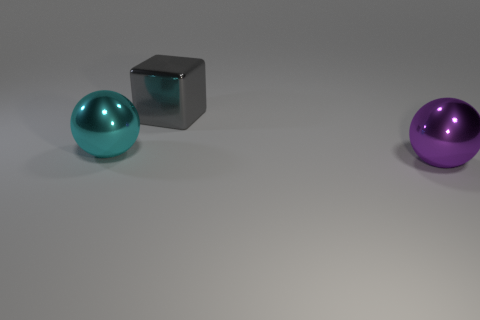The cyan sphere is what size?
Provide a short and direct response. Large. There is a large gray object that is made of the same material as the large purple ball; what shape is it?
Provide a short and direct response. Cube. There is a large thing to the right of the gray block; is it the same shape as the large cyan object?
Your answer should be compact. Yes. How many objects are cyan metal things or small brown matte objects?
Provide a short and direct response. 1. There is a object that is to the right of the cyan metallic sphere and left of the big purple ball; what is its material?
Offer a very short reply. Metal. Is the size of the gray shiny cube the same as the cyan object?
Offer a terse response. Yes. What number of large shiny balls are both on the right side of the big block and on the left side of the large gray object?
Your response must be concise. 0. Is there a object that is behind the big object that is in front of the shiny ball to the left of the purple object?
Keep it short and to the point. Yes. There is a cyan object that is the same size as the purple metallic object; what shape is it?
Keep it short and to the point. Sphere. Does the big purple object have the same shape as the cyan thing?
Offer a terse response. Yes. 